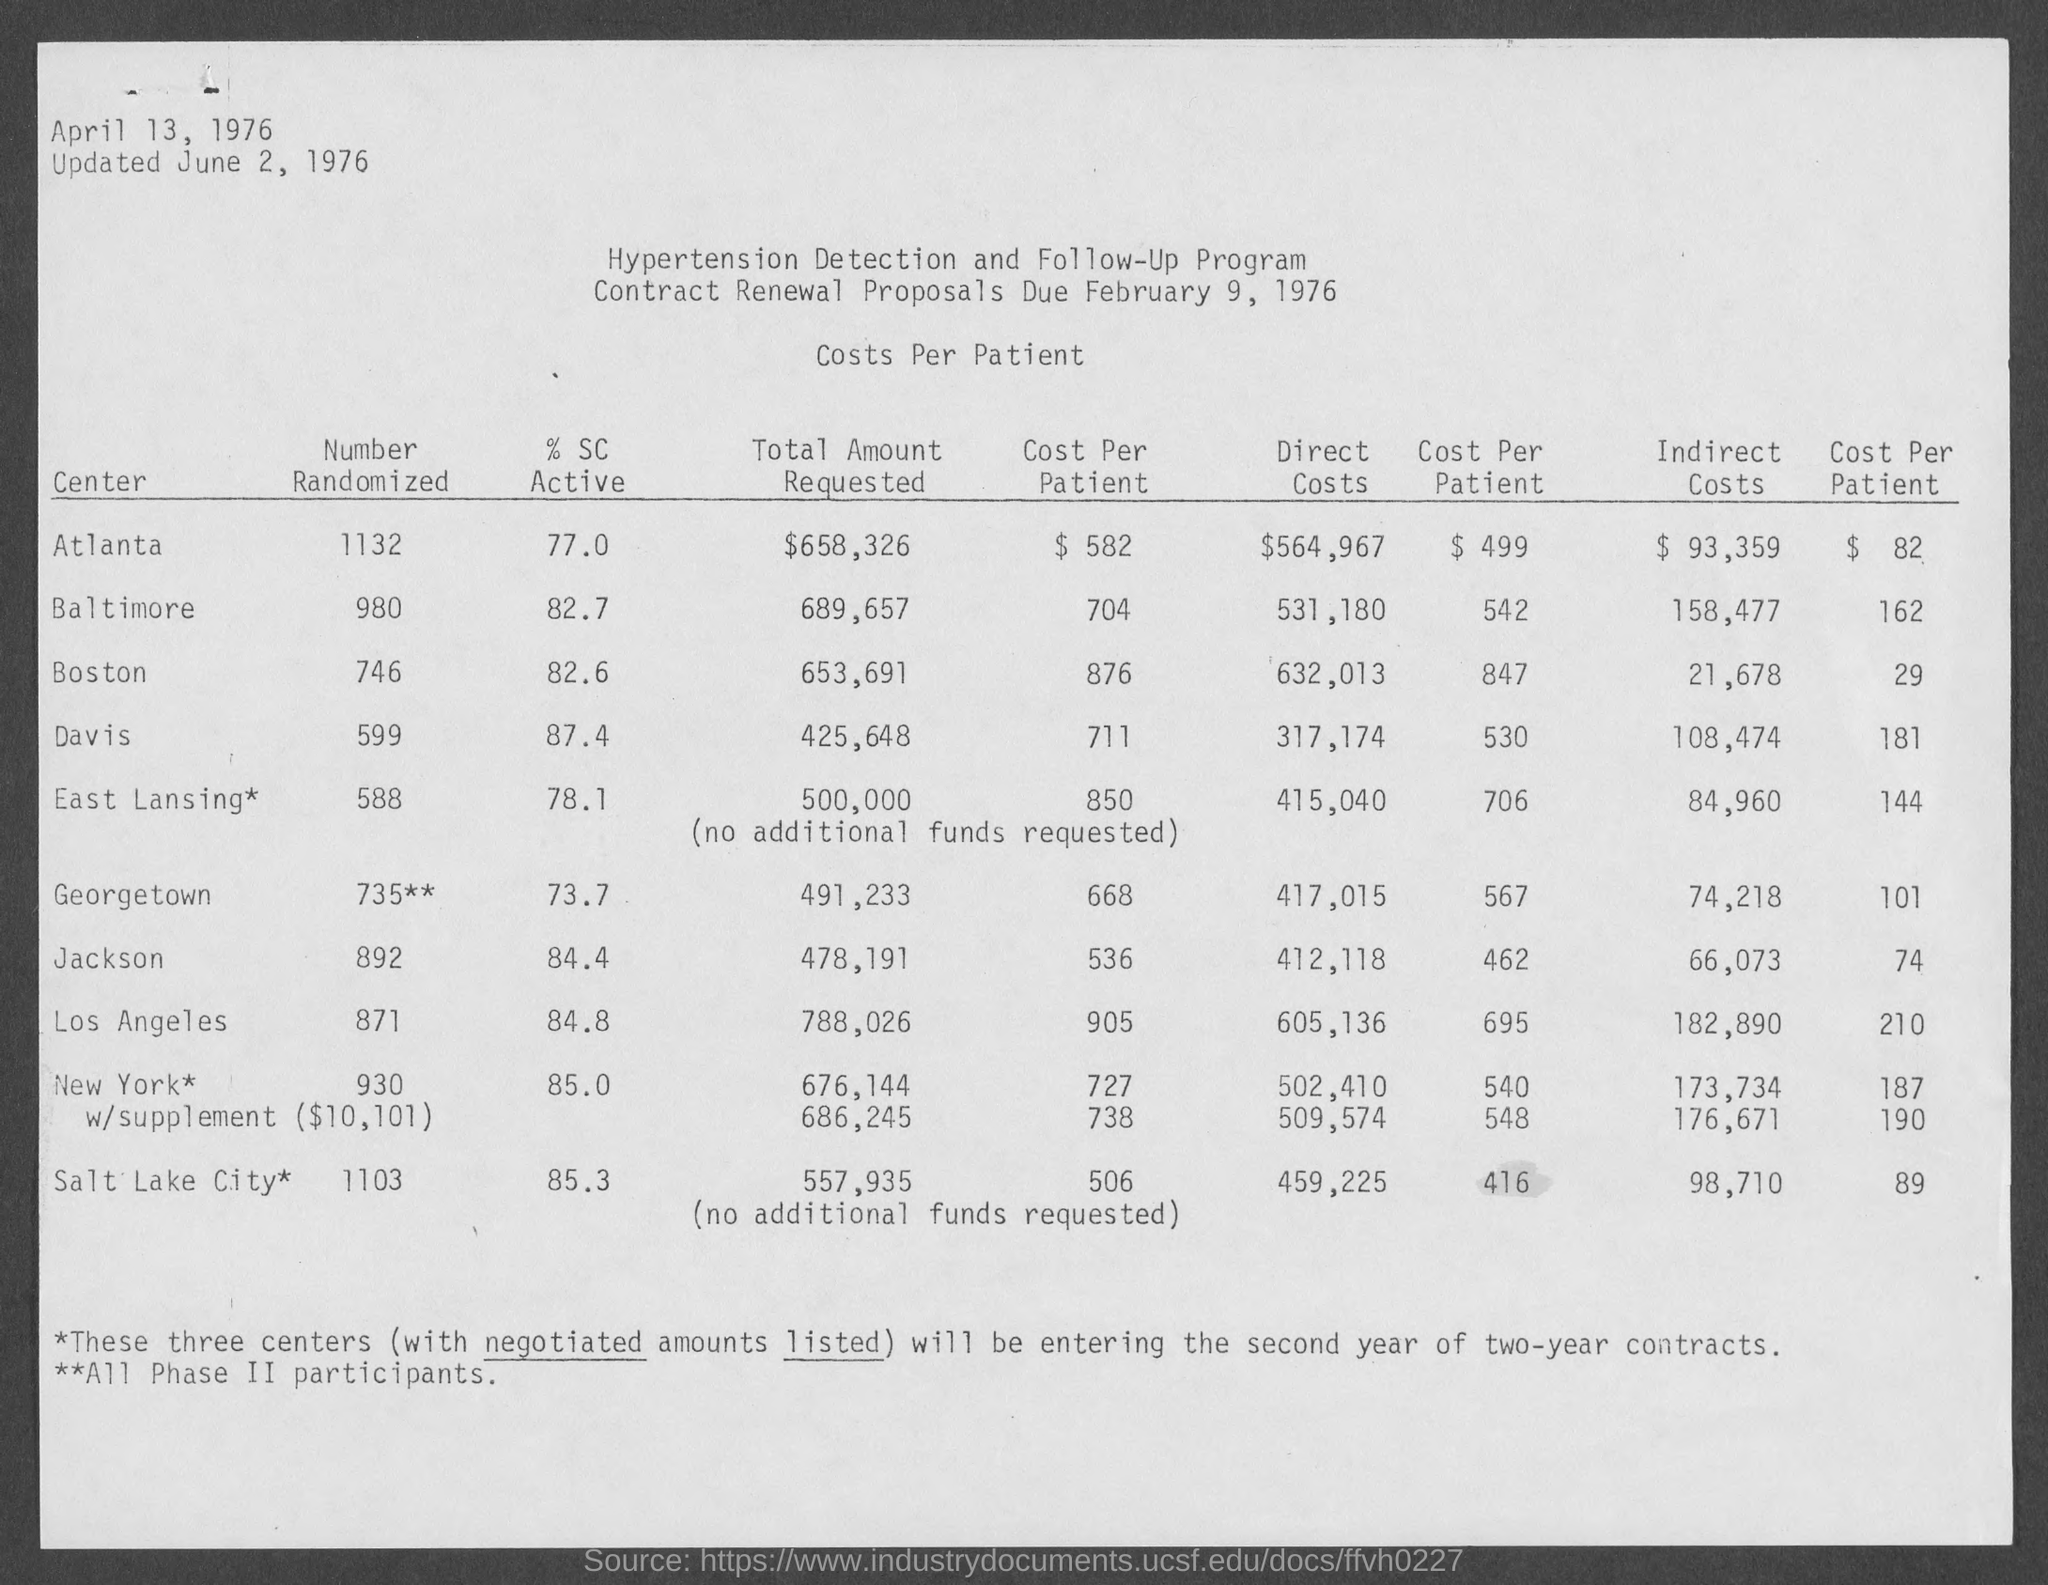What is the title of the table?
Keep it short and to the point. Costs per patient. What is number randomized for atlanta?
Give a very brief answer. 1132. What is the total amount requested for atlanta?
Keep it short and to the point. $658,326. What are direct costs for atlanta?
Offer a very short reply. $564,967. What are indirect costs for atlanta?
Provide a succinct answer. $93,359. What is the name of program?
Your response must be concise. Hypertension Detection and Follow-Up Program. 